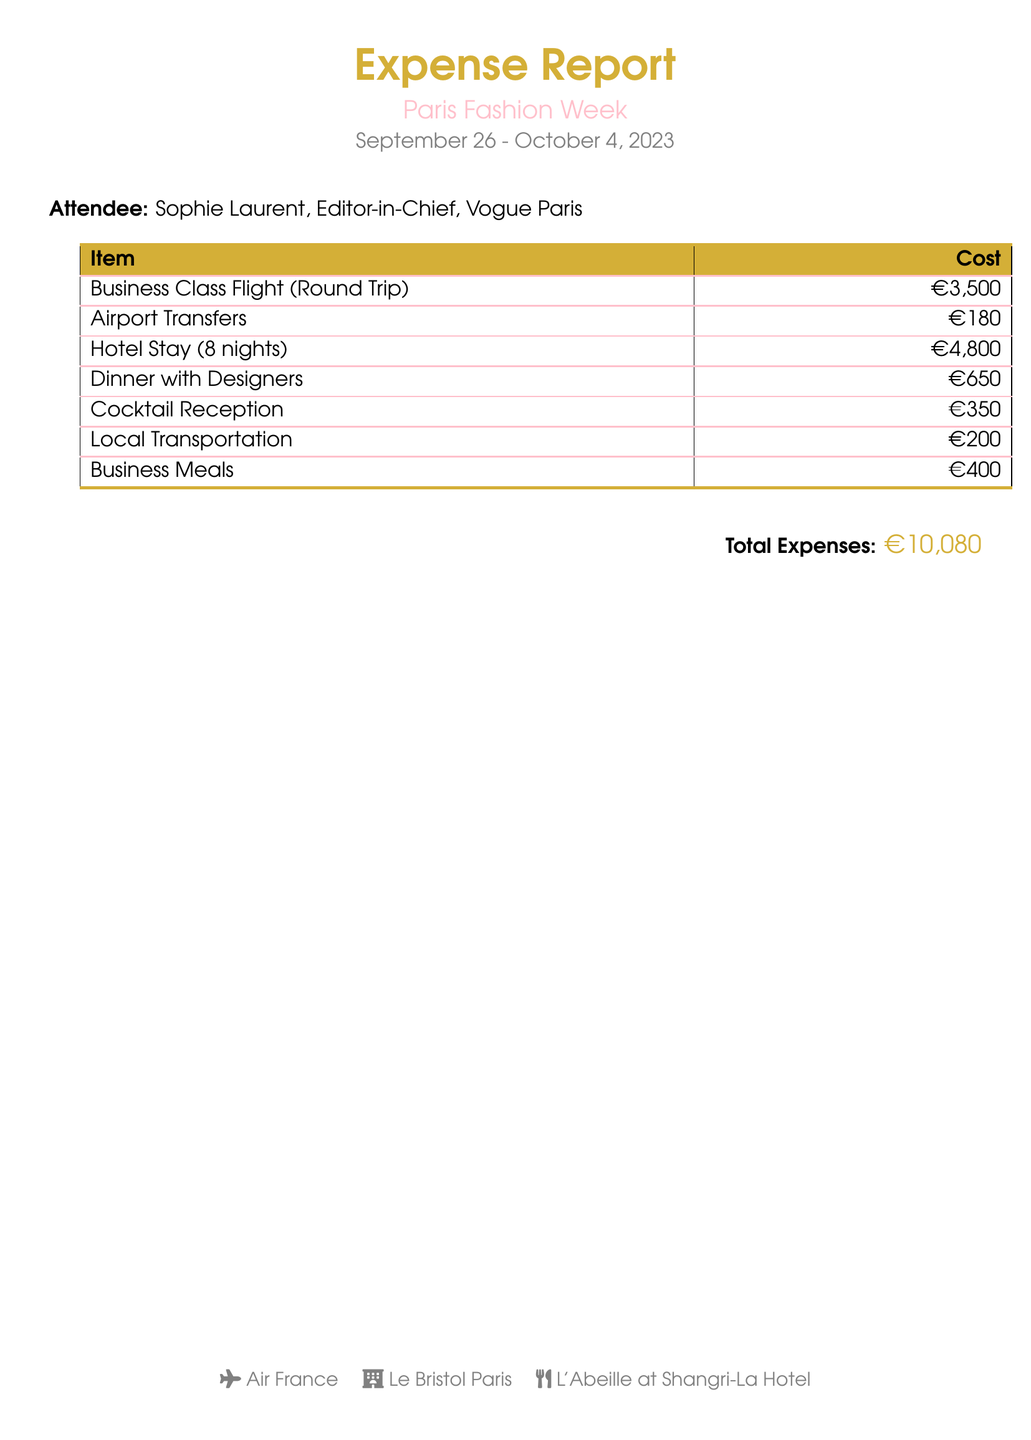what is the total expense? The total expenses are presented at the bottom of the document as a sum of individual costs.
Answer: €10,080 who is the attendee? The name and title of the attendee are listed at the start of the document.
Answer: Sophie Laurent, Editor-in-Chief, Vogue Paris how many nights was the hotel stay? The duration of the hotel stay is specified in the cost section of the document.
Answer: 8 nights what was the cost of the business class flight? The cost of the business class flight is explicitly listed in the expense report.
Answer: €3,500 what is the cost of dinner with designers? The expense section provides a specific cost for the dinner with designers.
Answer: €650 how much was spent on local transportation? The document includes a line item for local transportation expenses.
Answer: €200 who was the airline provider? The airline provider is mentioned at the end of the document with an icon.
Answer: Air France what was the accommodation name? The hotel where the attendee stayed is provided in the footer of the document.
Answer: Le Bristol Paris how much did the cocktail reception cost? The cost for the cocktail reception is detailed in the expense report.
Answer: €350 